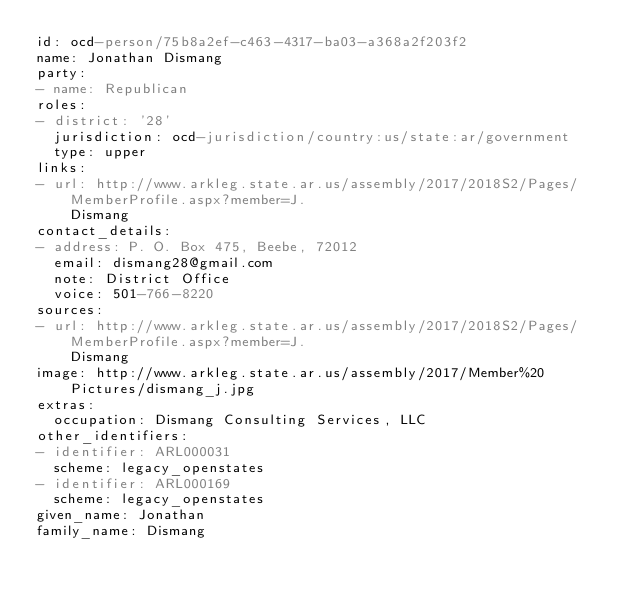Convert code to text. <code><loc_0><loc_0><loc_500><loc_500><_YAML_>id: ocd-person/75b8a2ef-c463-4317-ba03-a368a2f203f2
name: Jonathan Dismang
party:
- name: Republican
roles:
- district: '28'
  jurisdiction: ocd-jurisdiction/country:us/state:ar/government
  type: upper
links:
- url: http://www.arkleg.state.ar.us/assembly/2017/2018S2/Pages/MemberProfile.aspx?member=J.
    Dismang
contact_details:
- address: P. O. Box 475, Beebe, 72012
  email: dismang28@gmail.com
  note: District Office
  voice: 501-766-8220
sources:
- url: http://www.arkleg.state.ar.us/assembly/2017/2018S2/Pages/MemberProfile.aspx?member=J.
    Dismang
image: http://www.arkleg.state.ar.us/assembly/2017/Member%20Pictures/dismang_j.jpg
extras:
  occupation: Dismang Consulting Services, LLC
other_identifiers:
- identifier: ARL000031
  scheme: legacy_openstates
- identifier: ARL000169
  scheme: legacy_openstates
given_name: Jonathan
family_name: Dismang
</code> 